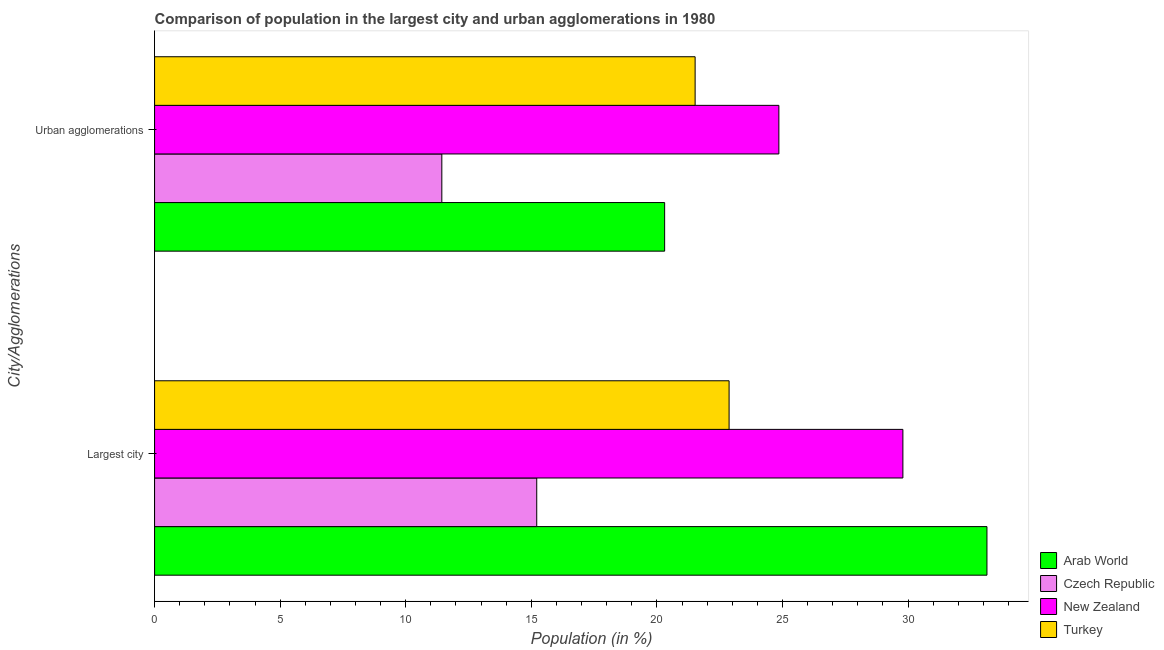Are the number of bars per tick equal to the number of legend labels?
Ensure brevity in your answer.  Yes. Are the number of bars on each tick of the Y-axis equal?
Your response must be concise. Yes. How many bars are there on the 2nd tick from the bottom?
Your answer should be very brief. 4. What is the label of the 1st group of bars from the top?
Provide a short and direct response. Urban agglomerations. What is the population in the largest city in Turkey?
Your response must be concise. 22.88. Across all countries, what is the maximum population in urban agglomerations?
Your answer should be compact. 24.86. Across all countries, what is the minimum population in the largest city?
Provide a succinct answer. 15.22. In which country was the population in the largest city maximum?
Your answer should be very brief. Arab World. In which country was the population in the largest city minimum?
Your answer should be very brief. Czech Republic. What is the total population in the largest city in the graph?
Your answer should be compact. 101.03. What is the difference between the population in the largest city in Arab World and that in Turkey?
Offer a very short reply. 10.27. What is the difference between the population in urban agglomerations in Arab World and the population in the largest city in Czech Republic?
Your answer should be very brief. 5.09. What is the average population in urban agglomerations per country?
Your response must be concise. 19.53. What is the difference between the population in urban agglomerations and population in the largest city in Czech Republic?
Give a very brief answer. -3.78. In how many countries, is the population in the largest city greater than 24 %?
Provide a succinct answer. 2. What is the ratio of the population in the largest city in New Zealand to that in Czech Republic?
Provide a succinct answer. 1.96. Is the population in the largest city in Czech Republic less than that in Turkey?
Give a very brief answer. Yes. In how many countries, is the population in the largest city greater than the average population in the largest city taken over all countries?
Give a very brief answer. 2. What does the 3rd bar from the top in Largest city represents?
Ensure brevity in your answer.  Czech Republic. What does the 4th bar from the bottom in Urban agglomerations represents?
Provide a succinct answer. Turkey. How many bars are there?
Provide a short and direct response. 8. Are all the bars in the graph horizontal?
Your response must be concise. Yes. How many countries are there in the graph?
Ensure brevity in your answer.  4. What is the difference between two consecutive major ticks on the X-axis?
Your response must be concise. 5. Are the values on the major ticks of X-axis written in scientific E-notation?
Offer a very short reply. No. Does the graph contain any zero values?
Your answer should be compact. No. Does the graph contain grids?
Provide a succinct answer. No. Where does the legend appear in the graph?
Offer a very short reply. Bottom right. How many legend labels are there?
Offer a terse response. 4. How are the legend labels stacked?
Your response must be concise. Vertical. What is the title of the graph?
Give a very brief answer. Comparison of population in the largest city and urban agglomerations in 1980. What is the label or title of the Y-axis?
Your response must be concise. City/Agglomerations. What is the Population (in %) in Arab World in Largest city?
Offer a terse response. 33.14. What is the Population (in %) of Czech Republic in Largest city?
Provide a short and direct response. 15.22. What is the Population (in %) in New Zealand in Largest city?
Keep it short and to the point. 29.79. What is the Population (in %) in Turkey in Largest city?
Ensure brevity in your answer.  22.88. What is the Population (in %) in Arab World in Urban agglomerations?
Provide a short and direct response. 20.31. What is the Population (in %) in Czech Republic in Urban agglomerations?
Offer a very short reply. 11.44. What is the Population (in %) of New Zealand in Urban agglomerations?
Provide a short and direct response. 24.86. What is the Population (in %) in Turkey in Urban agglomerations?
Offer a very short reply. 21.52. Across all City/Agglomerations, what is the maximum Population (in %) of Arab World?
Your answer should be very brief. 33.14. Across all City/Agglomerations, what is the maximum Population (in %) of Czech Republic?
Offer a terse response. 15.22. Across all City/Agglomerations, what is the maximum Population (in %) in New Zealand?
Provide a succinct answer. 29.79. Across all City/Agglomerations, what is the maximum Population (in %) in Turkey?
Offer a very short reply. 22.88. Across all City/Agglomerations, what is the minimum Population (in %) of Arab World?
Offer a very short reply. 20.31. Across all City/Agglomerations, what is the minimum Population (in %) of Czech Republic?
Provide a succinct answer. 11.44. Across all City/Agglomerations, what is the minimum Population (in %) of New Zealand?
Your answer should be compact. 24.86. Across all City/Agglomerations, what is the minimum Population (in %) in Turkey?
Make the answer very short. 21.52. What is the total Population (in %) of Arab World in the graph?
Make the answer very short. 53.45. What is the total Population (in %) in Czech Republic in the graph?
Offer a very short reply. 26.65. What is the total Population (in %) of New Zealand in the graph?
Offer a terse response. 54.65. What is the total Population (in %) in Turkey in the graph?
Keep it short and to the point. 44.4. What is the difference between the Population (in %) of Arab World in Largest city and that in Urban agglomerations?
Offer a terse response. 12.83. What is the difference between the Population (in %) of Czech Republic in Largest city and that in Urban agglomerations?
Keep it short and to the point. 3.78. What is the difference between the Population (in %) in New Zealand in Largest city and that in Urban agglomerations?
Provide a succinct answer. 4.94. What is the difference between the Population (in %) of Turkey in Largest city and that in Urban agglomerations?
Provide a short and direct response. 1.35. What is the difference between the Population (in %) in Arab World in Largest city and the Population (in %) in Czech Republic in Urban agglomerations?
Offer a terse response. 21.7. What is the difference between the Population (in %) in Arab World in Largest city and the Population (in %) in New Zealand in Urban agglomerations?
Provide a short and direct response. 8.28. What is the difference between the Population (in %) in Arab World in Largest city and the Population (in %) in Turkey in Urban agglomerations?
Provide a succinct answer. 11.62. What is the difference between the Population (in %) of Czech Republic in Largest city and the Population (in %) of New Zealand in Urban agglomerations?
Provide a short and direct response. -9.64. What is the difference between the Population (in %) of Czech Republic in Largest city and the Population (in %) of Turkey in Urban agglomerations?
Your answer should be very brief. -6.31. What is the difference between the Population (in %) in New Zealand in Largest city and the Population (in %) in Turkey in Urban agglomerations?
Make the answer very short. 8.27. What is the average Population (in %) of Arab World per City/Agglomerations?
Make the answer very short. 26.73. What is the average Population (in %) of Czech Republic per City/Agglomerations?
Provide a succinct answer. 13.33. What is the average Population (in %) of New Zealand per City/Agglomerations?
Keep it short and to the point. 27.33. What is the average Population (in %) in Turkey per City/Agglomerations?
Your response must be concise. 22.2. What is the difference between the Population (in %) of Arab World and Population (in %) of Czech Republic in Largest city?
Offer a terse response. 17.93. What is the difference between the Population (in %) in Arab World and Population (in %) in New Zealand in Largest city?
Provide a short and direct response. 3.35. What is the difference between the Population (in %) of Arab World and Population (in %) of Turkey in Largest city?
Offer a terse response. 10.27. What is the difference between the Population (in %) in Czech Republic and Population (in %) in New Zealand in Largest city?
Offer a terse response. -14.58. What is the difference between the Population (in %) in Czech Republic and Population (in %) in Turkey in Largest city?
Your answer should be compact. -7.66. What is the difference between the Population (in %) of New Zealand and Population (in %) of Turkey in Largest city?
Offer a terse response. 6.92. What is the difference between the Population (in %) in Arab World and Population (in %) in Czech Republic in Urban agglomerations?
Your answer should be compact. 8.87. What is the difference between the Population (in %) in Arab World and Population (in %) in New Zealand in Urban agglomerations?
Provide a succinct answer. -4.55. What is the difference between the Population (in %) in Arab World and Population (in %) in Turkey in Urban agglomerations?
Make the answer very short. -1.21. What is the difference between the Population (in %) in Czech Republic and Population (in %) in New Zealand in Urban agglomerations?
Your answer should be compact. -13.42. What is the difference between the Population (in %) of Czech Republic and Population (in %) of Turkey in Urban agglomerations?
Provide a succinct answer. -10.08. What is the difference between the Population (in %) of New Zealand and Population (in %) of Turkey in Urban agglomerations?
Your response must be concise. 3.33. What is the ratio of the Population (in %) in Arab World in Largest city to that in Urban agglomerations?
Provide a short and direct response. 1.63. What is the ratio of the Population (in %) of Czech Republic in Largest city to that in Urban agglomerations?
Give a very brief answer. 1.33. What is the ratio of the Population (in %) in New Zealand in Largest city to that in Urban agglomerations?
Ensure brevity in your answer.  1.2. What is the ratio of the Population (in %) in Turkey in Largest city to that in Urban agglomerations?
Offer a very short reply. 1.06. What is the difference between the highest and the second highest Population (in %) of Arab World?
Your response must be concise. 12.83. What is the difference between the highest and the second highest Population (in %) of Czech Republic?
Your answer should be compact. 3.78. What is the difference between the highest and the second highest Population (in %) in New Zealand?
Provide a short and direct response. 4.94. What is the difference between the highest and the second highest Population (in %) in Turkey?
Give a very brief answer. 1.35. What is the difference between the highest and the lowest Population (in %) of Arab World?
Your response must be concise. 12.83. What is the difference between the highest and the lowest Population (in %) of Czech Republic?
Offer a very short reply. 3.78. What is the difference between the highest and the lowest Population (in %) of New Zealand?
Provide a succinct answer. 4.94. What is the difference between the highest and the lowest Population (in %) in Turkey?
Your answer should be very brief. 1.35. 